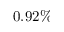Convert formula to latex. <formula><loc_0><loc_0><loc_500><loc_500>0 . 9 2 \%</formula> 